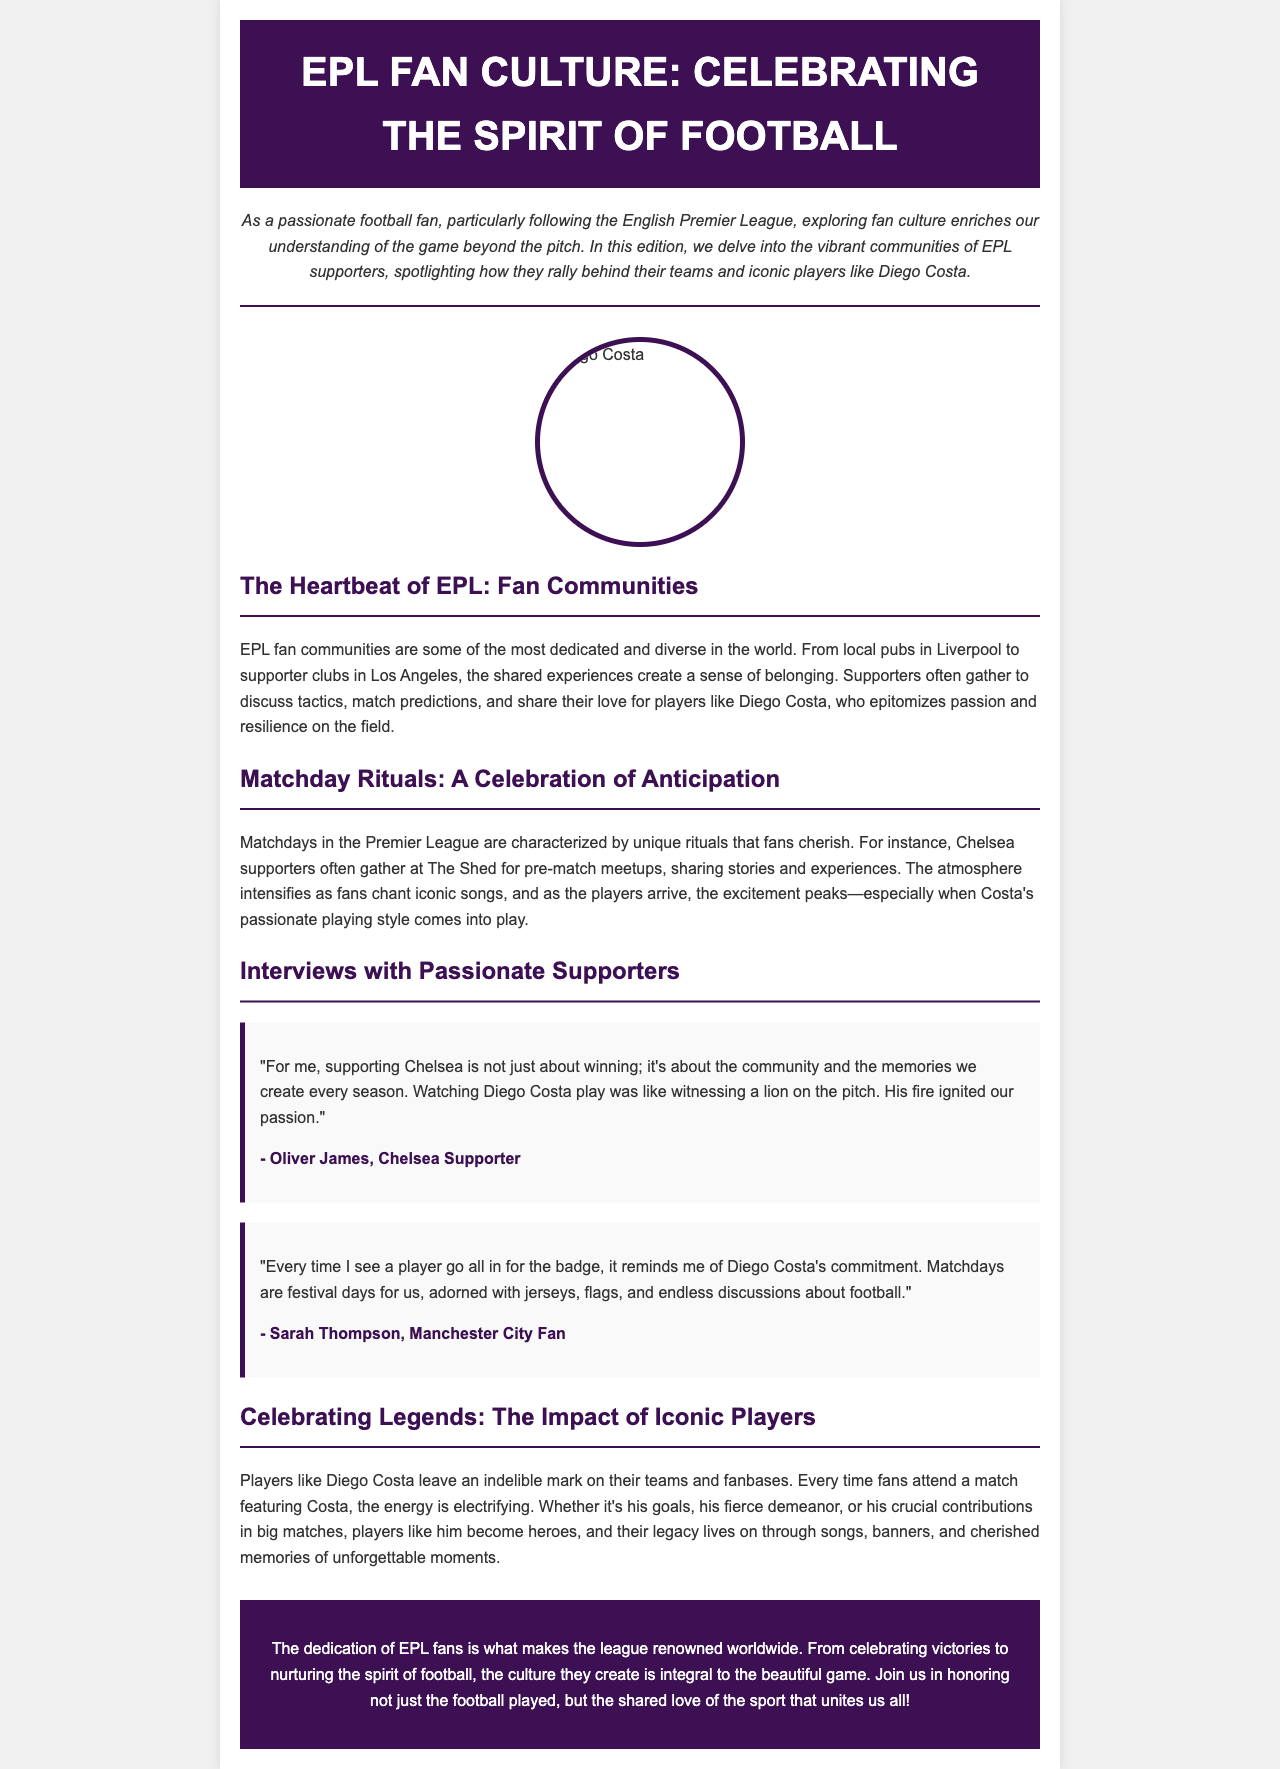what is the title of the newsletter? The title of the newsletter is prominently displayed in the header section.
Answer: EPL Fan Culture: Celebrating the Spirit of Football who is the hero mentioned in the newsletter? The newsletter highlights the passion of fans for a specific player, referring to him as a hero.
Answer: Diego Costa what is the name of the Chelsea supporter interviewed? The newsletter includes quotes from various supporters, including one whose name is mentioned.
Answer: Oliver James how do Chelsea supporters celebrate on matchdays according to the document? The document describes the activities Chelsea supporters engage in on matchdays.
Answer: Gathering at The Shed what do fans associate with Diego Costa's playing style? The document highlights the perception of Diego Costa's style by the fans during matches.
Answer: Passionate playing style how do fans describe matchdays? The newsletter captures how fans feel about the days when matches are played.
Answer: Festival days what color is used for the header in the document? The header section features a specific color that is consistent throughout the design.
Answer: Dark purple how does the document describe the impact of iconic players like Diego Costa? The newsletter discusses the significant effects these players have on their fanbase.
Answer: Indelible mark 